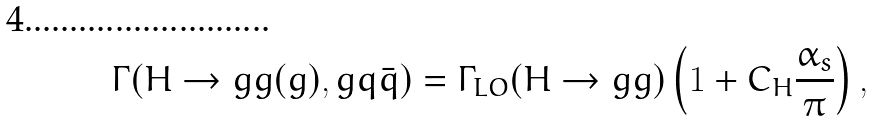<formula> <loc_0><loc_0><loc_500><loc_500>\Gamma ( H \to g g ( g ) , g q \bar { q } ) = \Gamma _ { L O } ( H \to g g ) \left ( 1 + C _ { H } \frac { \alpha _ { s } } { \pi } \right ) ,</formula> 